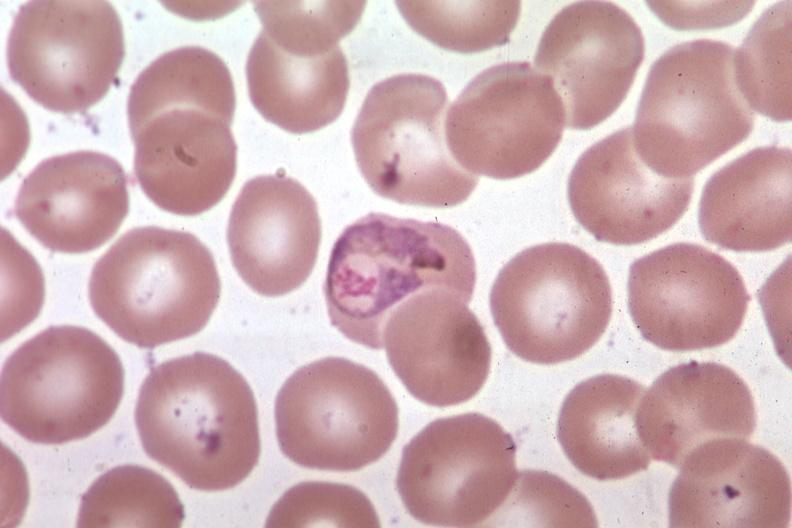what is present?
Answer the question using a single word or phrase. Blood 